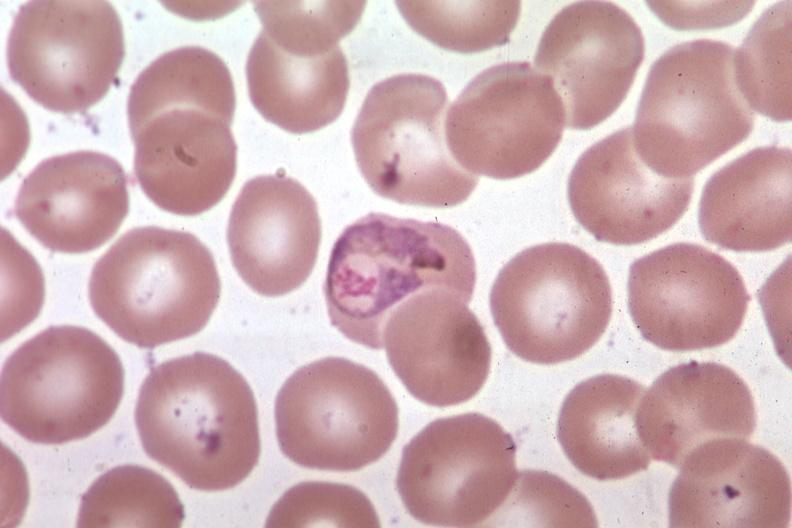what is present?
Answer the question using a single word or phrase. Blood 